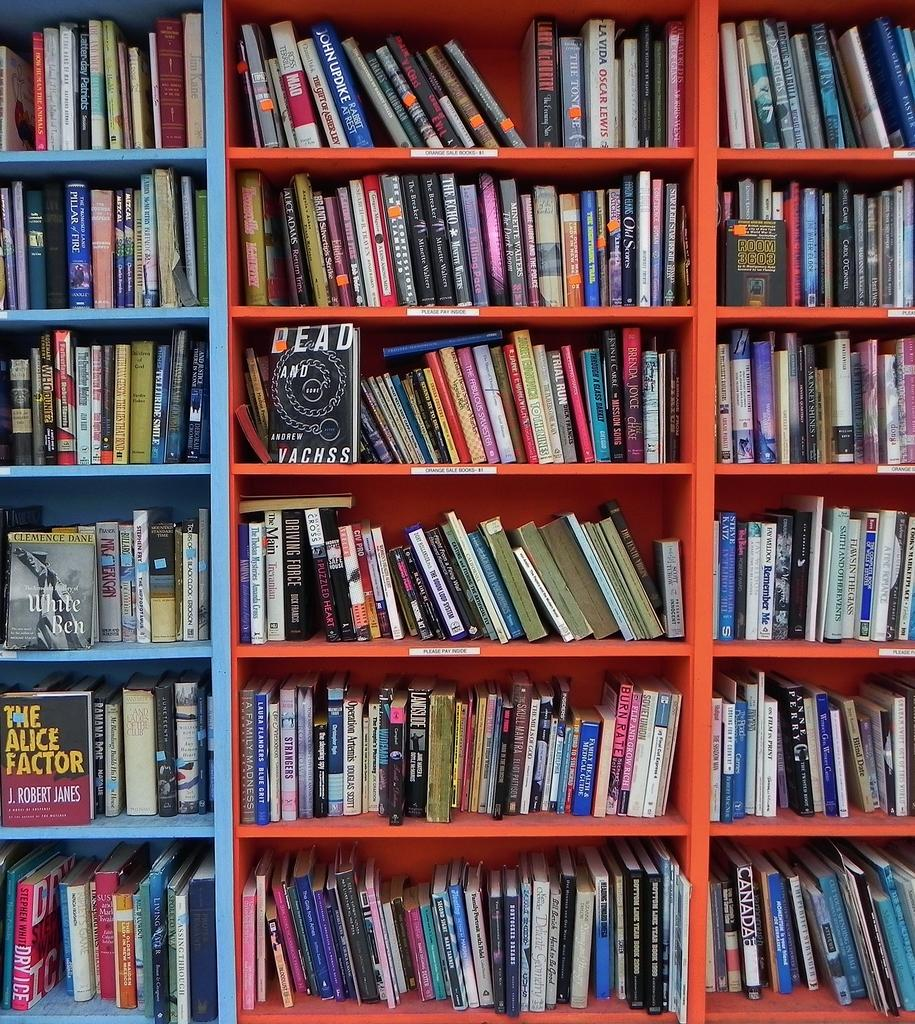What type of furniture is present in the image? There is a bookshelf in the image. What might be stored on the bookshelf? Books, decorative items, or other objects might be stored on the bookshelf. Can you describe the purpose of a bookshelf? A bookshelf is typically used for storing and organizing books, magazines, or other reading materials. How many cherries are on the bookshelf in the image? There is no mention of cherries in the image, so it is not possible to determine their presence or quantity. 